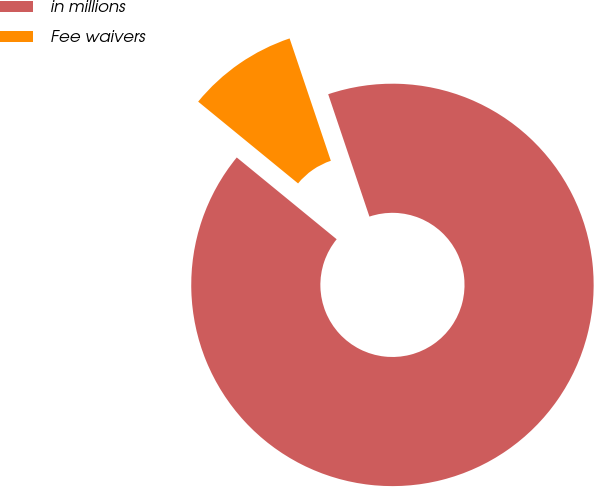Convert chart. <chart><loc_0><loc_0><loc_500><loc_500><pie_chart><fcel>in millions<fcel>Fee waivers<nl><fcel>91.09%<fcel>8.91%<nl></chart> 